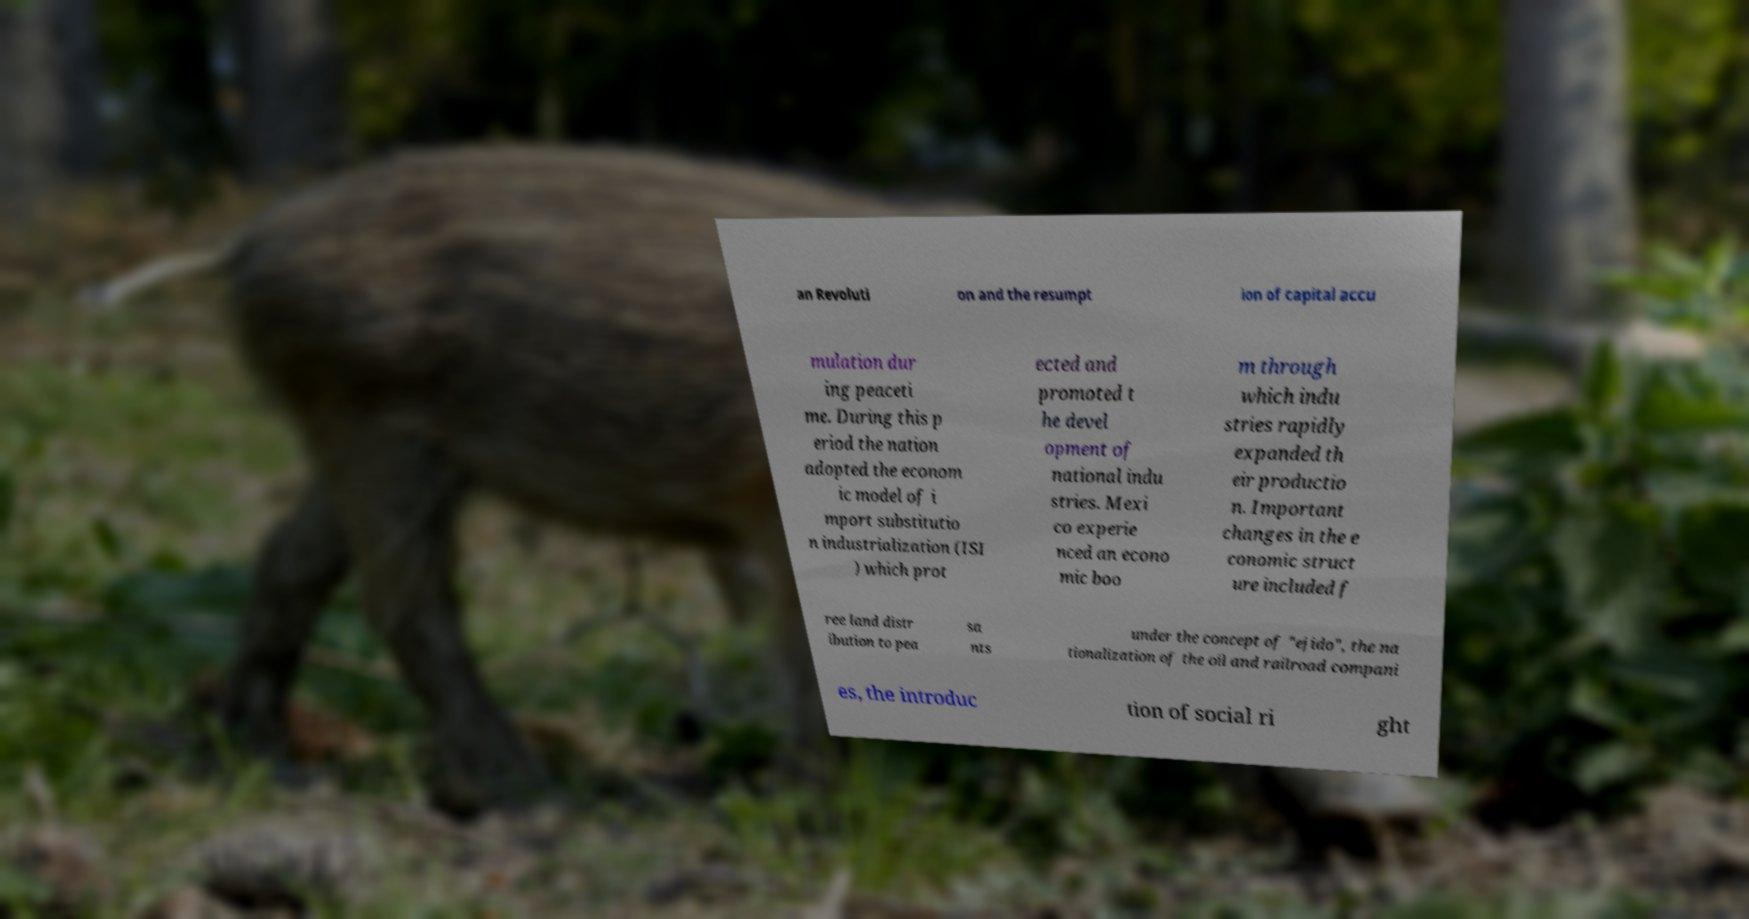For documentation purposes, I need the text within this image transcribed. Could you provide that? an Revoluti on and the resumpt ion of capital accu mulation dur ing peaceti me. During this p eriod the nation adopted the econom ic model of i mport substitutio n industrialization (ISI ) which prot ected and promoted t he devel opment of national indu stries. Mexi co experie nced an econo mic boo m through which indu stries rapidly expanded th eir productio n. Important changes in the e conomic struct ure included f ree land distr ibution to pea sa nts under the concept of "ejido", the na tionalization of the oil and railroad compani es, the introduc tion of social ri ght 